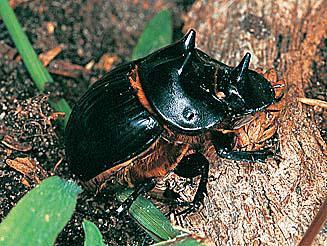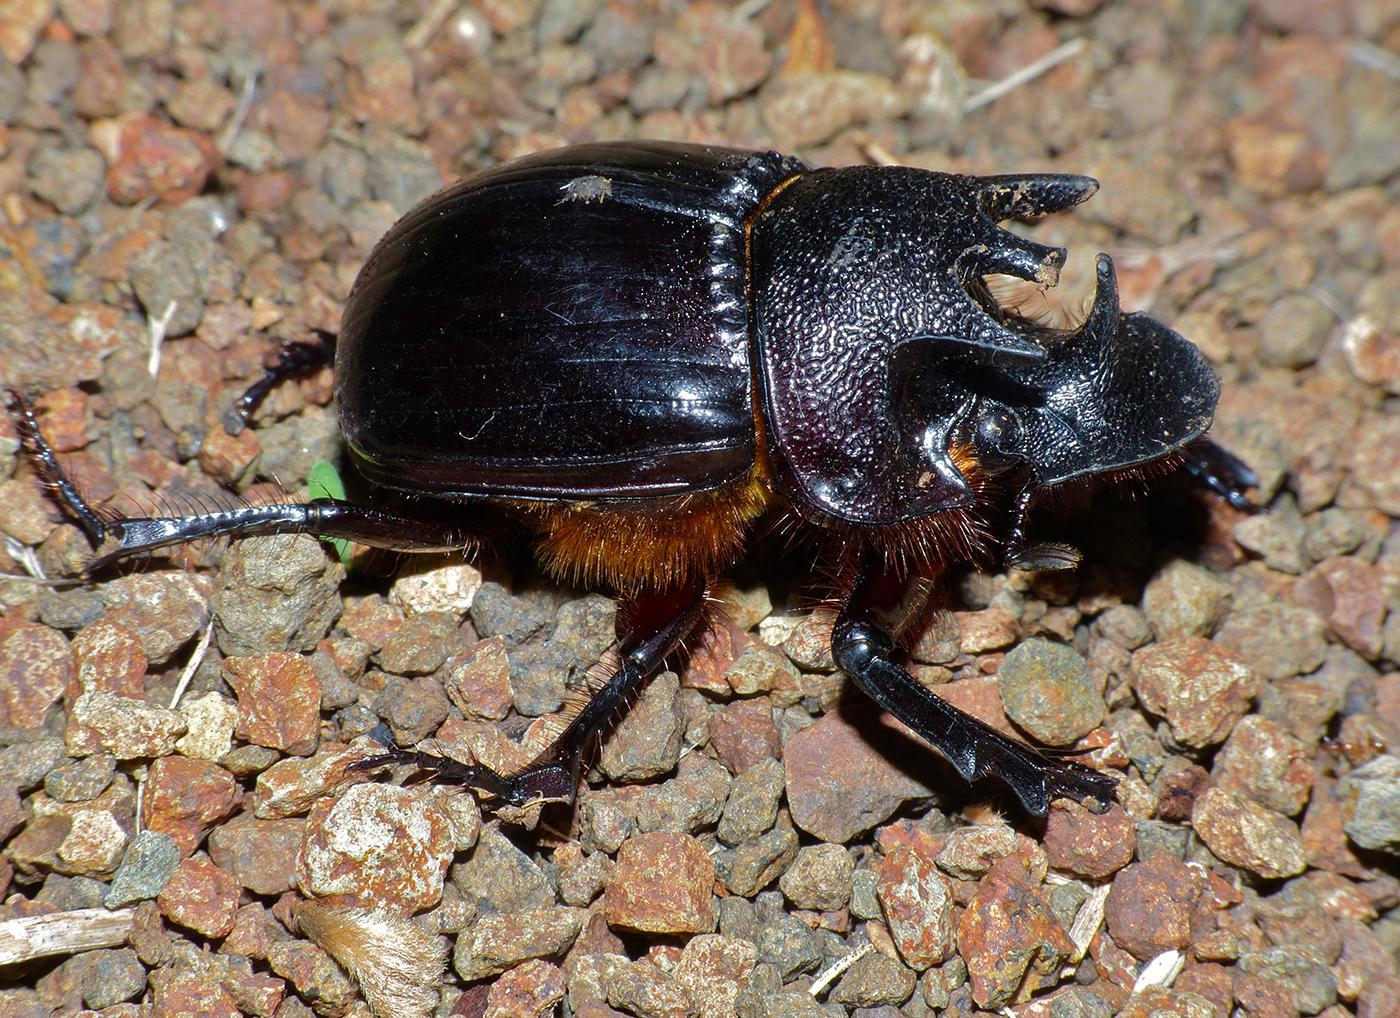The first image is the image on the left, the second image is the image on the right. Assess this claim about the two images: "One image shows the underside of a beetle instead of the top side.". Correct or not? Answer yes or no. No. The first image is the image on the left, the second image is the image on the right. Analyze the images presented: Is the assertion "The beetle on the left is near green grass." valid? Answer yes or no. Yes. 